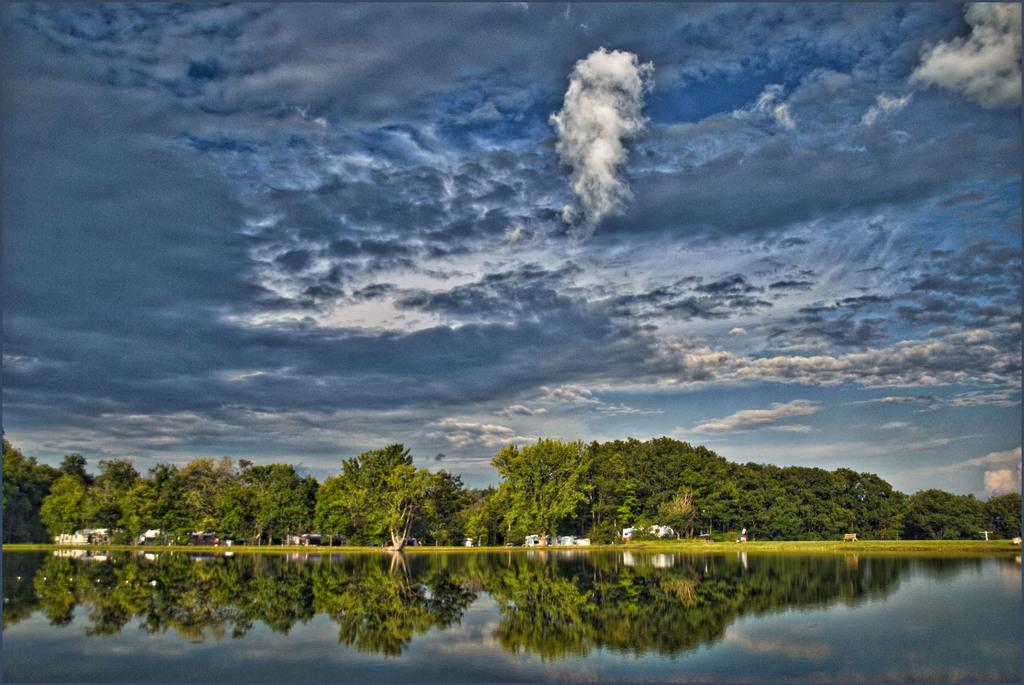What is the main feature in the foreground of the image? There is a water body in the foreground of the image. What can be seen in the background of the image? There are trees and buildings in the background of the image. How would you describe the sky in the image? The sky is cloudy in the image. What year is depicted in the image? The image does not depict a specific year; it is a photograph of a scene that could have been taken at any time. Can you tell me how many fields are visible in the image? There are no fields visible in the image; it features a water body, trees, buildings, and a cloudy sky. 